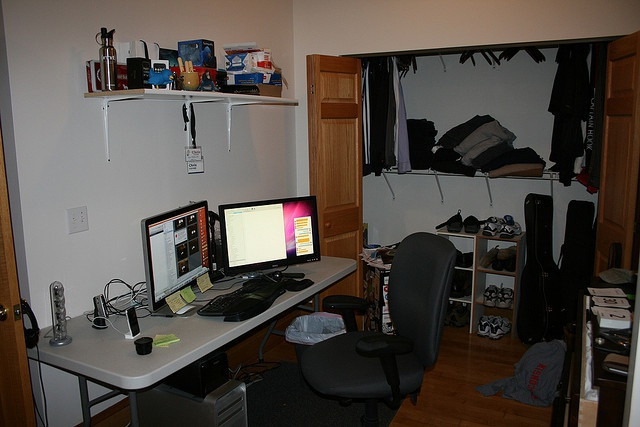Describe the objects in this image and their specific colors. I can see chair in black, gray, and maroon tones, tv in black, beige, and violet tones, tv in black, darkgray, gray, and maroon tones, keyboard in black and gray tones, and book in black, gray, and darkgray tones in this image. 